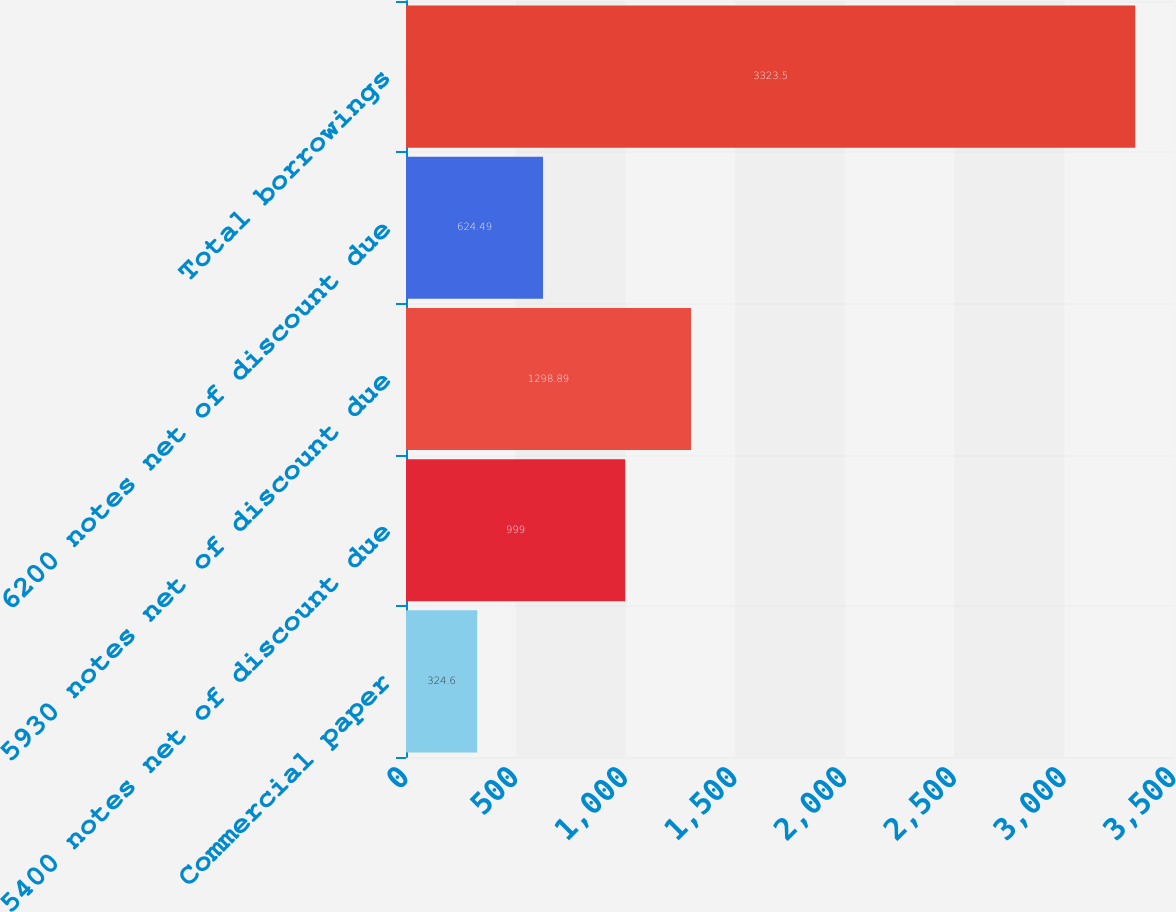Convert chart. <chart><loc_0><loc_0><loc_500><loc_500><bar_chart><fcel>Commercial paper<fcel>5400 notes net of discount due<fcel>5930 notes net of discount due<fcel>6200 notes net of discount due<fcel>Total borrowings<nl><fcel>324.6<fcel>999<fcel>1298.89<fcel>624.49<fcel>3323.5<nl></chart> 